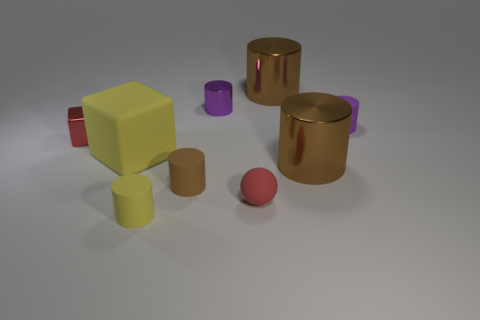What is the ball made of?
Ensure brevity in your answer.  Rubber. What size is the purple metal object that is the same shape as the small yellow thing?
Ensure brevity in your answer.  Small. Is the ball the same color as the large matte object?
Keep it short and to the point. No. What number of other things are there of the same material as the tiny cube
Your response must be concise. 3. Are there the same number of small metallic objects on the left side of the big rubber cube and tiny purple shiny cylinders?
Your response must be concise. Yes. There is a yellow thing that is behind the yellow cylinder; is its size the same as the tiny red ball?
Your answer should be compact. No. There is a matte cube; how many tiny metal things are behind it?
Make the answer very short. 2. What material is the small thing that is both in front of the small red metal cube and left of the small brown cylinder?
Give a very brief answer. Rubber. What number of tiny things are yellow cylinders or matte balls?
Your answer should be compact. 2. What is the size of the yellow matte block?
Ensure brevity in your answer.  Large. 